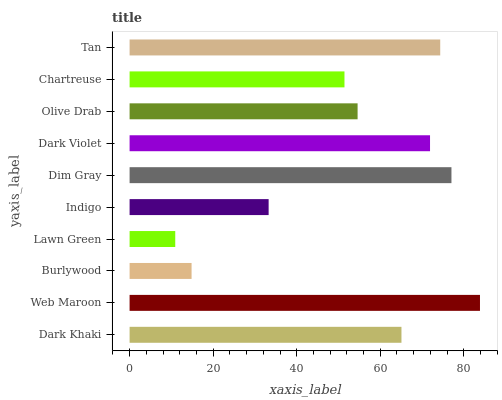Is Lawn Green the minimum?
Answer yes or no. Yes. Is Web Maroon the maximum?
Answer yes or no. Yes. Is Burlywood the minimum?
Answer yes or no. No. Is Burlywood the maximum?
Answer yes or no. No. Is Web Maroon greater than Burlywood?
Answer yes or no. Yes. Is Burlywood less than Web Maroon?
Answer yes or no. Yes. Is Burlywood greater than Web Maroon?
Answer yes or no. No. Is Web Maroon less than Burlywood?
Answer yes or no. No. Is Dark Khaki the high median?
Answer yes or no. Yes. Is Olive Drab the low median?
Answer yes or no. Yes. Is Indigo the high median?
Answer yes or no. No. Is Burlywood the low median?
Answer yes or no. No. 